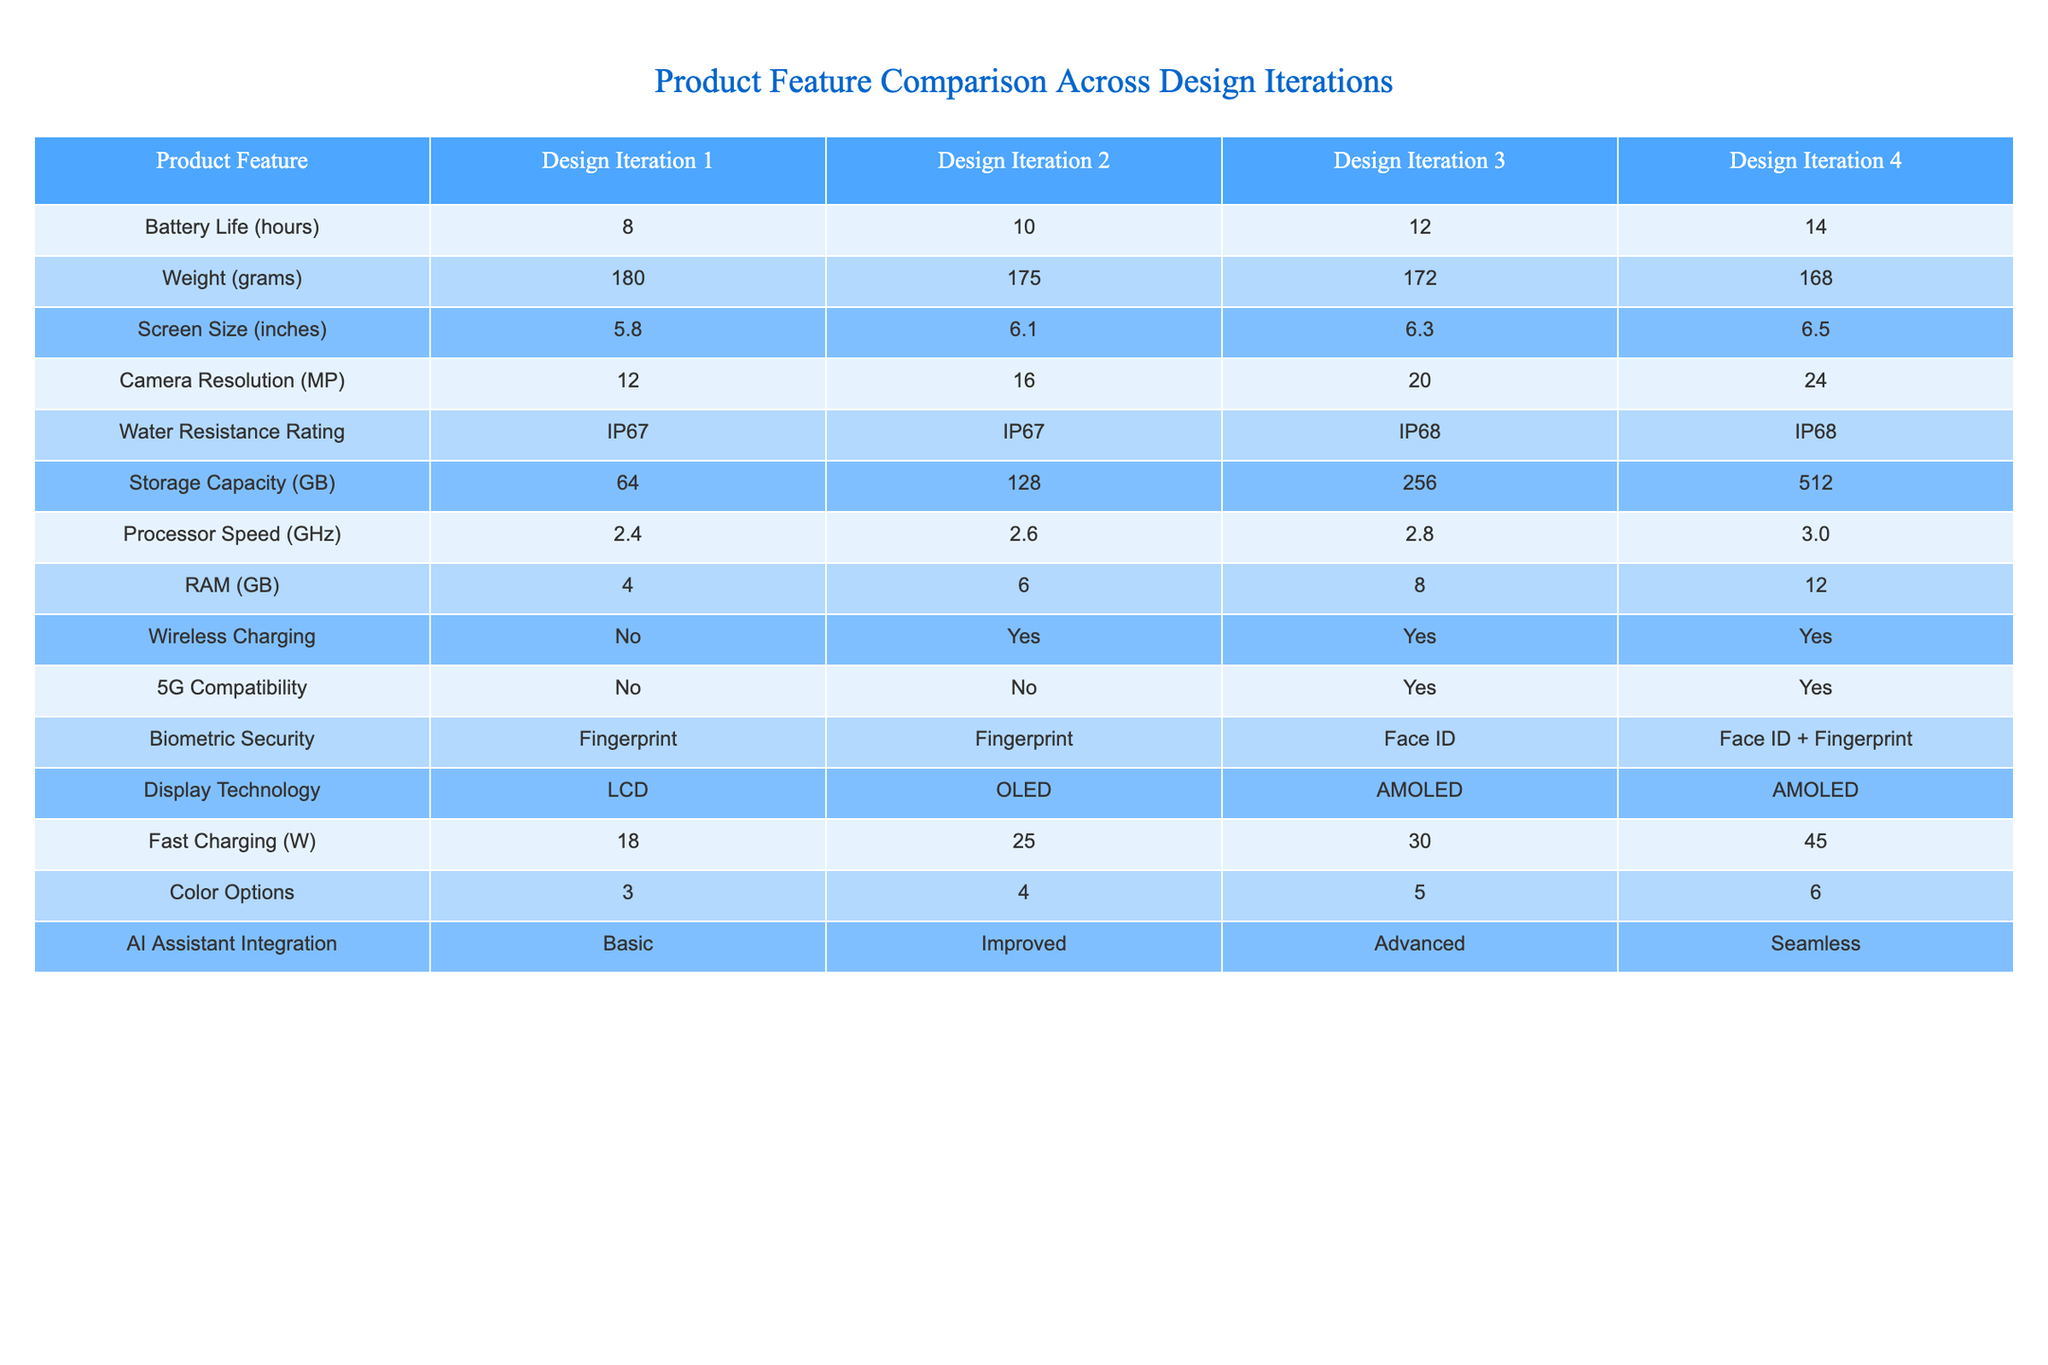What is the camera resolution in Design Iteration 4? The table shows that the camera resolution in Design Iteration 4 is listed under the "Camera Resolution" row and the "Design Iteration 4" column, which reads 24 MP.
Answer: 24 MP What is the weight difference between Design Iteration 1 and Design Iteration 3? The weight in Design Iteration 1 is 180 grams and in Design Iteration 3 is 172 grams. The difference is calculated as 180 - 172 = 8 grams.
Answer: 8 grams Is the product compatible with 5G in Design Iteration 3? The table indicates that the 5G compatibility for Design Iteration 3 is marked with "Yes" under the "5G Compatibility" row.
Answer: Yes What is the average battery life across all design iterations? The battery life values are 8, 10, 12, and 14 hours. Adding them gives 44 hours, and dividing by 4 (the number of iterations) results in an average of 44 / 4 = 11 hours.
Answer: 11 hours What is the fastest processor speed achieved in the design iterations? From the table, the processor speeds across iterations are 2.4, 2.6, 2.8, and 3.0 GHz. The highest value here is 3.0 GHz in Design Iteration 4.
Answer: 3.0 GHz How does the storage capacity of Design Iteration 2 compare to Design Iteration 4? The storage capacities are 128 GB for Design Iteration 2 and 512 GB for Design Iteration 4. Therefore, 512 - 128 = 384 GB difference in favor of Iteration 4.
Answer: 384 GB more Which design iteration has the highest water resistance rating? The water resistance ratings are IP67 for Designs 1 and 2, and IP68 for Designs 3 and 4. Since both Designs 3 and 4 have IP68, they are the highest.
Answer: IP68 What is the total number of color options available in Design Iteration 4? The "Color Options" row shows that Design Iteration 4 has 6 color options as stated in the table under that category.
Answer: 6 What is the percentage increase in RAM from Design Iteration 1 to Design Iteration 4? RAM values are 4 GB for Iteration 1 and 12 GB for Iteration 4. The increase is 12 - 4 = 8 GB. The percentage increase is (8 / 4) * 100 = 200%.
Answer: 200% In which design iteration is AI Assistant Integration considered “Seamless”? The integration marked as "Seamless" is under Design Iteration 4 according to the table.
Answer: Design Iteration 4 How many features in Design Iteration 3 have improved from Design Iteration 1? Comparing features, the ones that improved are Battery Life, Camera Resolution, RAM, Storage Capacity, and Fast Charging. This totals 5 features that show improvement.
Answer: 5 features 